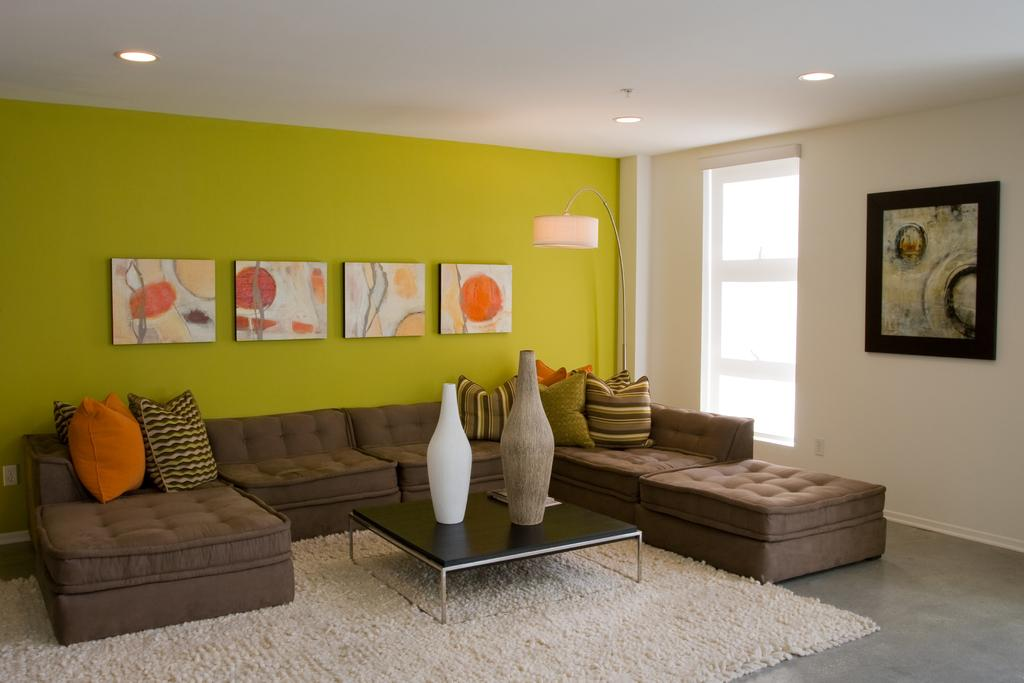What is the color of the wall in the image? The wall in the image is green. What type of lighting fixture can be seen in the image? There is a lamp in the image. Is there any source of natural light in the image? Yes, there is a window in the image. What type of decorative item is present in the image? There is a photo frame in the image. What type of furniture is present in the image? There are sofas in the image. What type of accessory is present on the sofas? There are pillows in the image. What is placed in front of the sofa? There is a table in front of the sofa. What type of items are on the table? There are pots on the table. What type of scientific apparatus is present in the image? There is no scientific apparatus present in the image. What type of straw is used to decorate the sofas in the image? There are no straws present in the image, and the sofas are not decorated with straw. 